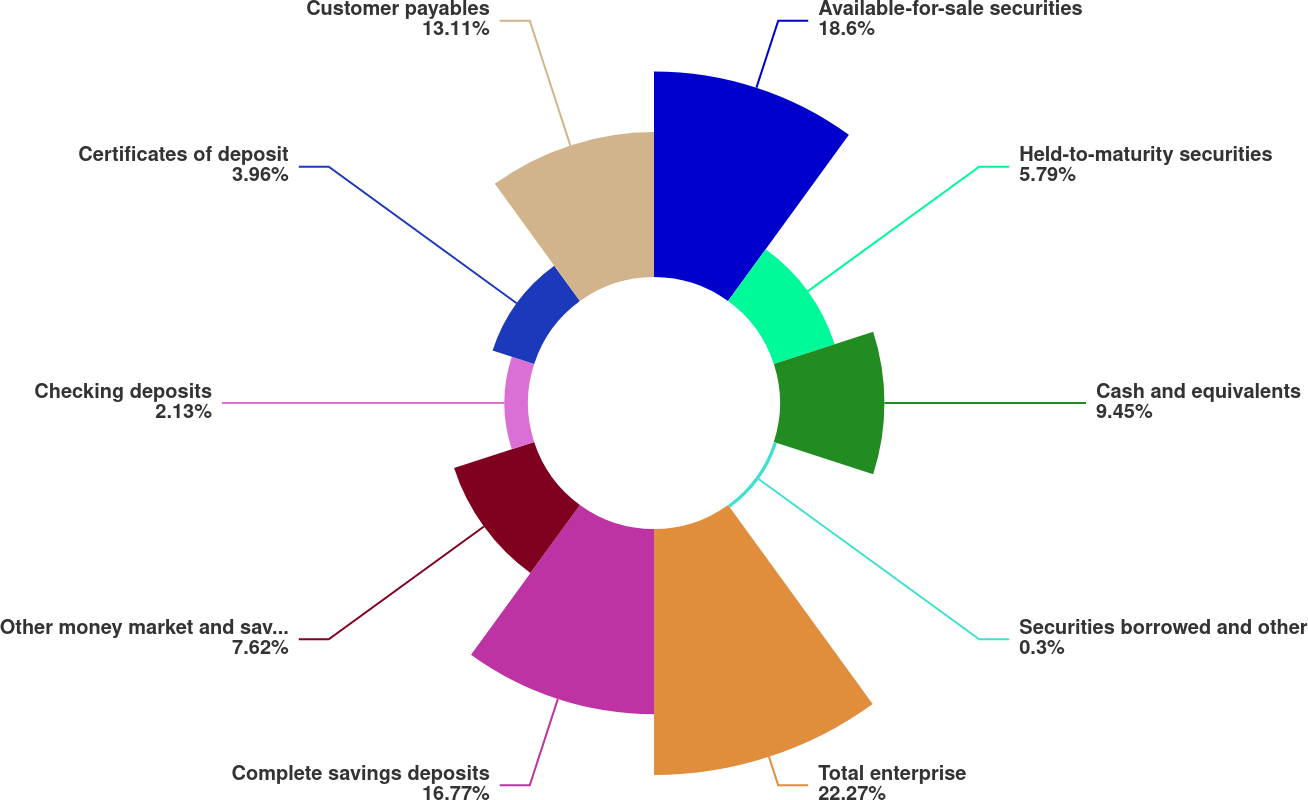Convert chart. <chart><loc_0><loc_0><loc_500><loc_500><pie_chart><fcel>Available-for-sale securities<fcel>Held-to-maturity securities<fcel>Cash and equivalents<fcel>Securities borrowed and other<fcel>Total enterprise<fcel>Complete savings deposits<fcel>Other money market and savings<fcel>Checking deposits<fcel>Certificates of deposit<fcel>Customer payables<nl><fcel>18.6%<fcel>5.79%<fcel>9.45%<fcel>0.3%<fcel>22.26%<fcel>16.77%<fcel>7.62%<fcel>2.13%<fcel>3.96%<fcel>13.11%<nl></chart> 